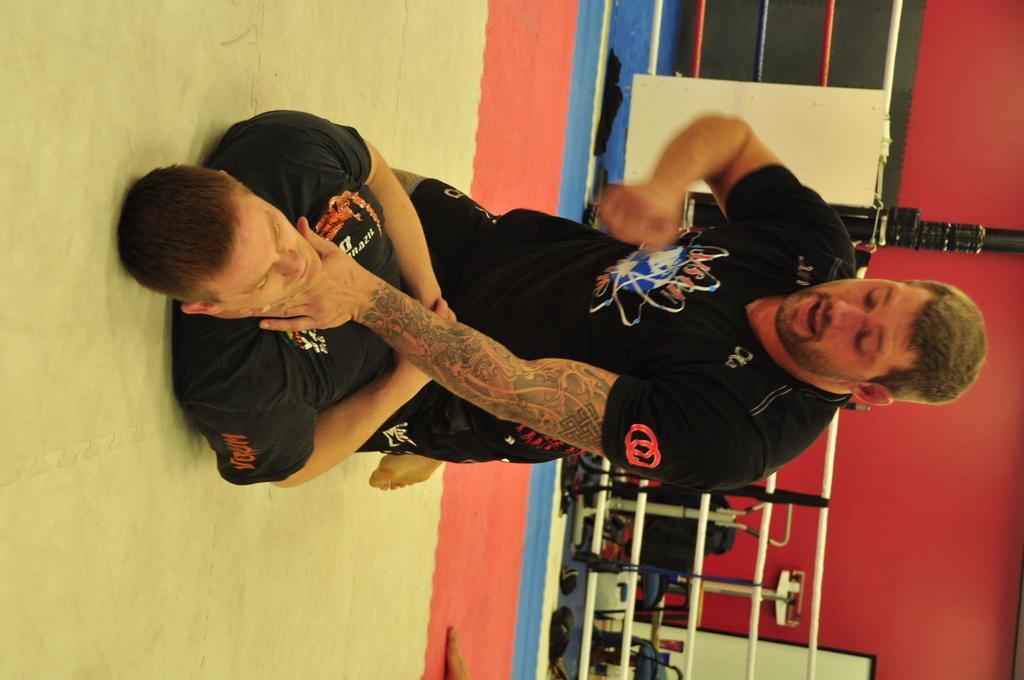Can you describe this image briefly? At the left side of the image there is a man on the floor. On the man there is another man sitting. Behind them there is a black pole with ropes. In the background there are few items and also there is a red wall. 